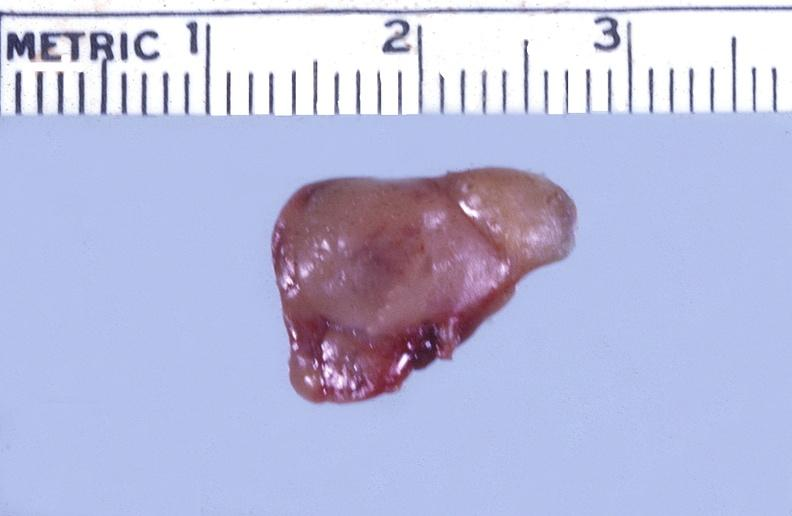does this section showing liver with tumor mass in hilar area tumor show parathyroid, functional adenoma?
Answer the question using a single word or phrase. No 